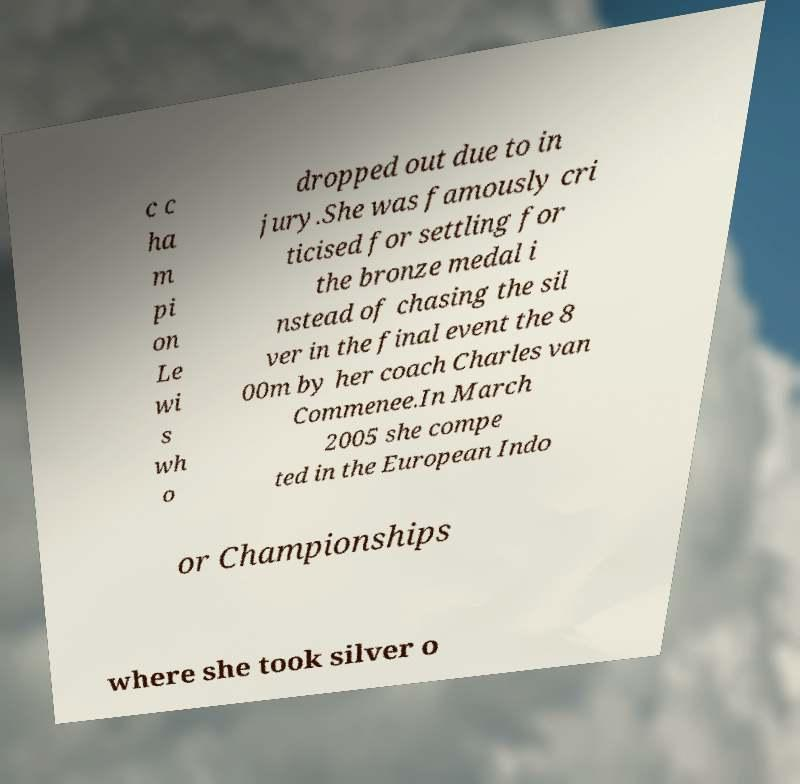There's text embedded in this image that I need extracted. Can you transcribe it verbatim? c c ha m pi on Le wi s wh o dropped out due to in jury.She was famously cri ticised for settling for the bronze medal i nstead of chasing the sil ver in the final event the 8 00m by her coach Charles van Commenee.In March 2005 she compe ted in the European Indo or Championships where she took silver o 